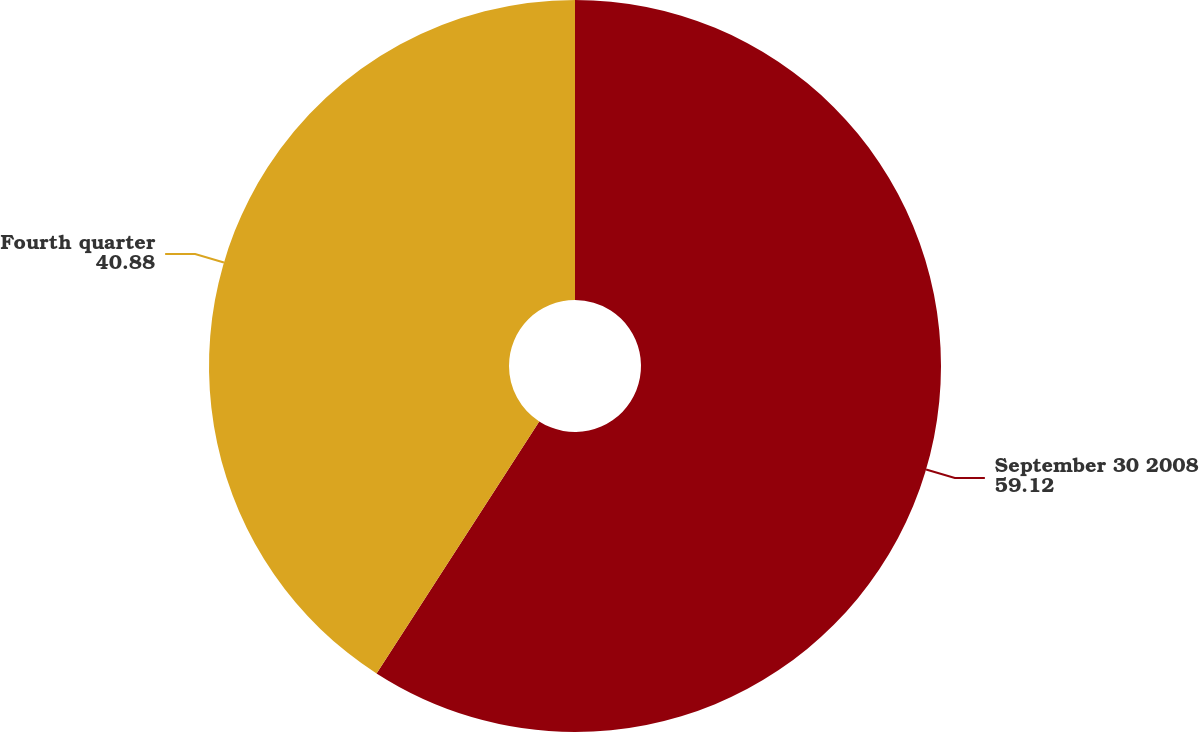Convert chart to OTSL. <chart><loc_0><loc_0><loc_500><loc_500><pie_chart><fcel>September 30 2008<fcel>Fourth quarter<nl><fcel>59.12%<fcel>40.88%<nl></chart> 